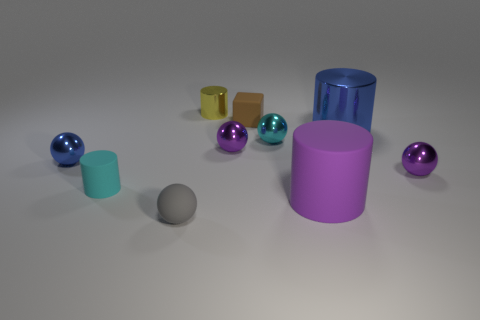Do the purple cylinder and the cyan metal sphere have the same size?
Ensure brevity in your answer.  No. Does the tiny cyan thing left of the small rubber sphere have the same material as the large purple cylinder?
Make the answer very short. Yes. What number of cyan objects are behind the small ball that is in front of the tiny matte object left of the gray matte sphere?
Ensure brevity in your answer.  2. Do the purple thing to the right of the large blue object and the purple matte object have the same shape?
Keep it short and to the point. No. Is the number of gray balls behind the tiny shiny cylinder the same as the number of large rubber objects that are to the left of the small gray ball?
Offer a terse response. Yes. There is a cylinder that is right of the big matte thing; is there a tiny ball on the left side of it?
Your answer should be very brief. Yes. There is a object that is the same color as the tiny rubber cylinder; what size is it?
Your answer should be compact. Small. What size is the purple sphere behind the tiny purple thing that is to the right of the cyan metallic sphere?
Make the answer very short. Small. What is the size of the rubber object that is right of the small brown block?
Your answer should be compact. Large. Is the number of large purple rubber objects that are on the left side of the tiny block less than the number of tiny purple spheres that are left of the small yellow cylinder?
Offer a very short reply. No. 